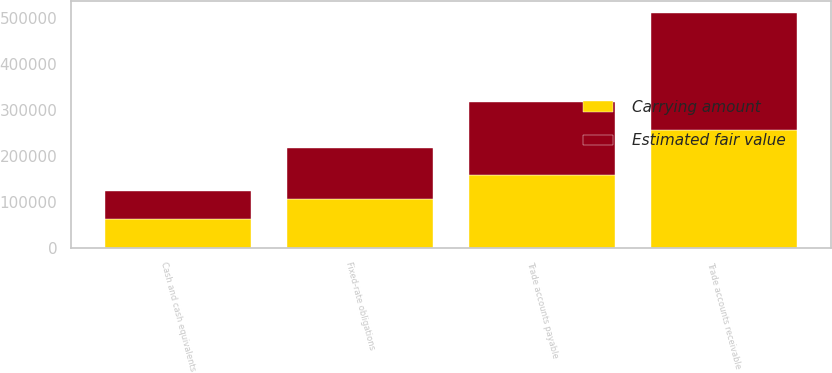Convert chart to OTSL. <chart><loc_0><loc_0><loc_500><loc_500><stacked_bar_chart><ecel><fcel>Cash and cash equivalents<fcel>Trade accounts receivable<fcel>Trade accounts payable<fcel>Fixed-rate obligations<nl><fcel>Carrying amount<fcel>61229<fcel>256032<fcel>158886<fcel>105000<nl><fcel>Estimated fair value<fcel>61229<fcel>256032<fcel>158886<fcel>111003<nl></chart> 